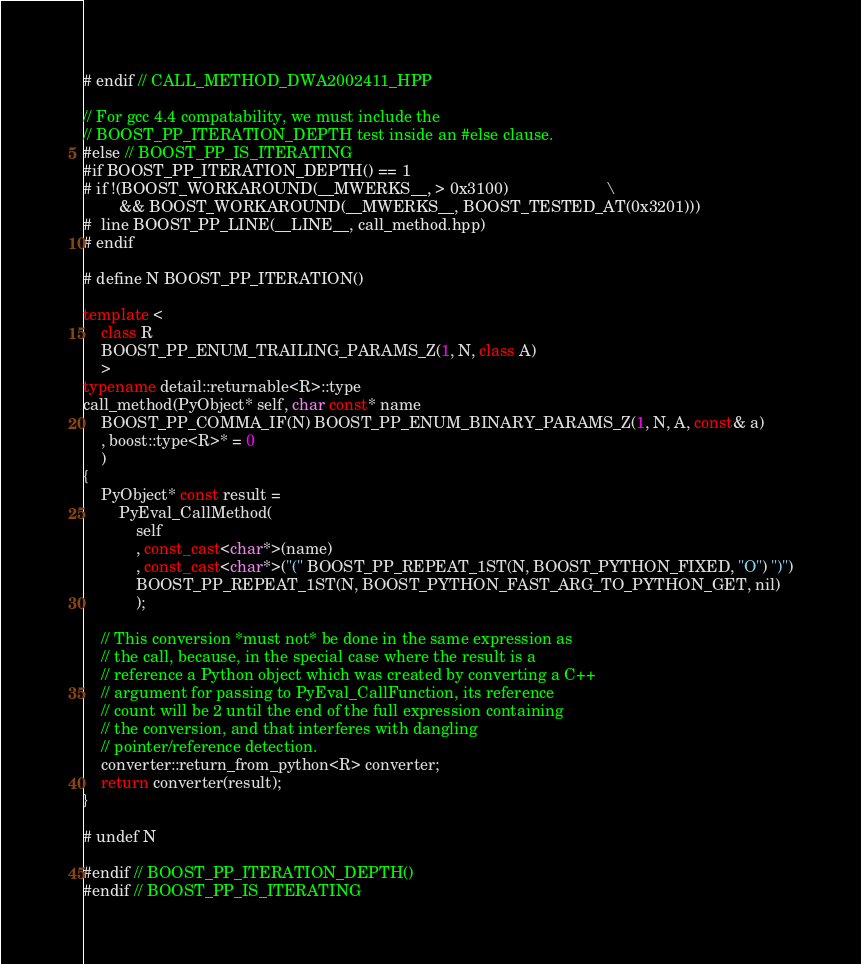<code> <loc_0><loc_0><loc_500><loc_500><_C++_># endif // CALL_METHOD_DWA2002411_HPP

// For gcc 4.4 compatability, we must include the
// BOOST_PP_ITERATION_DEPTH test inside an #else clause.
#else // BOOST_PP_IS_ITERATING
#if BOOST_PP_ITERATION_DEPTH() == 1
# if !(BOOST_WORKAROUND(__MWERKS__, > 0x3100)                      \
        && BOOST_WORKAROUND(__MWERKS__, BOOST_TESTED_AT(0x3201)))
#  line BOOST_PP_LINE(__LINE__, call_method.hpp)
# endif 

# define N BOOST_PP_ITERATION()

template <
    class R
    BOOST_PP_ENUM_TRAILING_PARAMS_Z(1, N, class A)
    >
typename detail::returnable<R>::type
call_method(PyObject* self, char const* name
    BOOST_PP_COMMA_IF(N) BOOST_PP_ENUM_BINARY_PARAMS_Z(1, N, A, const& a)
    , boost::type<R>* = 0
    )
{
    PyObject* const result = 
        PyEval_CallMethod(
            self
            , const_cast<char*>(name)
            , const_cast<char*>("(" BOOST_PP_REPEAT_1ST(N, BOOST_PYTHON_FIXED, "O") ")")
            BOOST_PP_REPEAT_1ST(N, BOOST_PYTHON_FAST_ARG_TO_PYTHON_GET, nil)
            );
    
    // This conversion *must not* be done in the same expression as
    // the call, because, in the special case where the result is a
    // reference a Python object which was created by converting a C++
    // argument for passing to PyEval_CallFunction, its reference
    // count will be 2 until the end of the full expression containing
    // the conversion, and that interferes with dangling
    // pointer/reference detection.
    converter::return_from_python<R> converter;
    return converter(result);
}

# undef N

#endif // BOOST_PP_ITERATION_DEPTH()
#endif // BOOST_PP_IS_ITERATING
</code> 